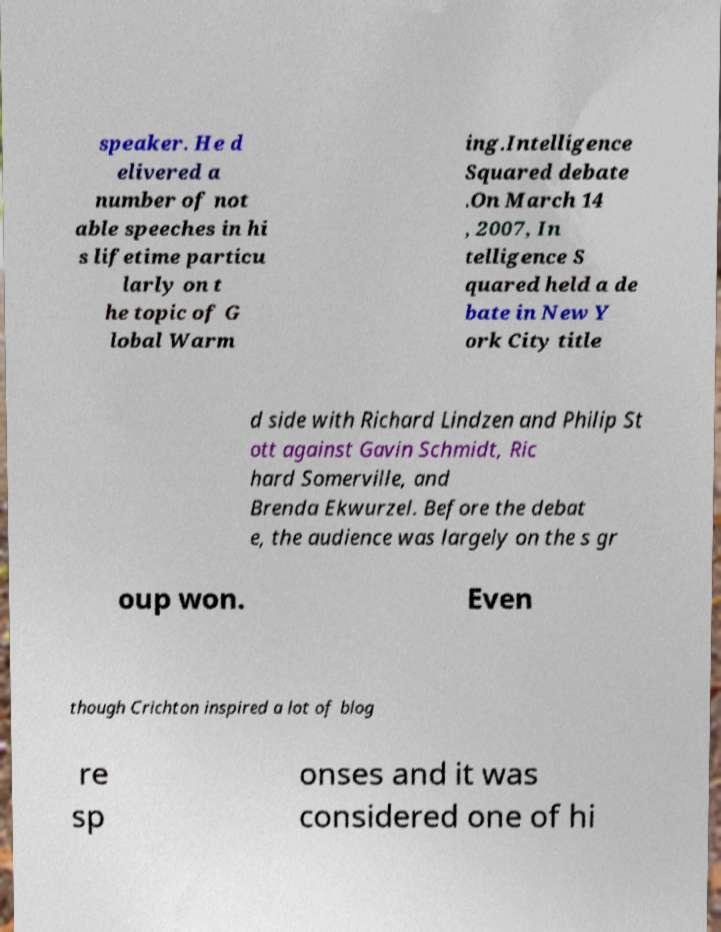Could you assist in decoding the text presented in this image and type it out clearly? speaker. He d elivered a number of not able speeches in hi s lifetime particu larly on t he topic of G lobal Warm ing.Intelligence Squared debate .On March 14 , 2007, In telligence S quared held a de bate in New Y ork City title d side with Richard Lindzen and Philip St ott against Gavin Schmidt, Ric hard Somerville, and Brenda Ekwurzel. Before the debat e, the audience was largely on the s gr oup won. Even though Crichton inspired a lot of blog re sp onses and it was considered one of hi 